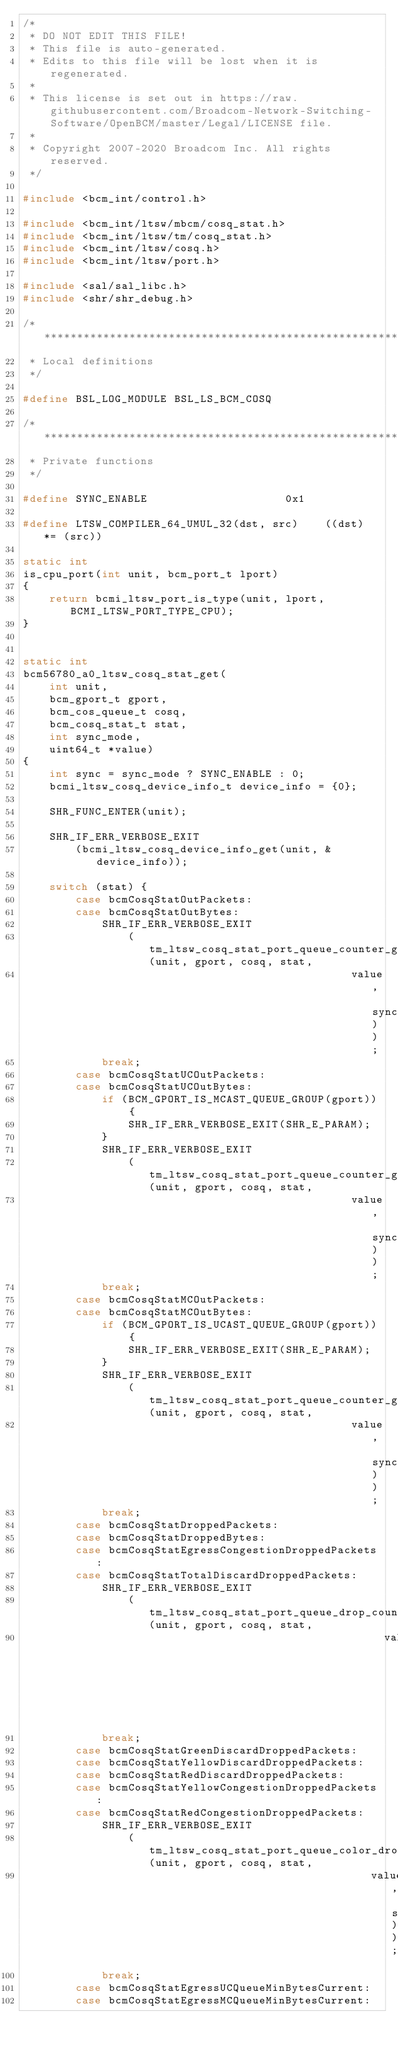<code> <loc_0><loc_0><loc_500><loc_500><_C_>/*
 * DO NOT EDIT THIS FILE!
 * This file is auto-generated.
 * Edits to this file will be lost when it is regenerated.
 *
 * This license is set out in https://raw.githubusercontent.com/Broadcom-Network-Switching-Software/OpenBCM/master/Legal/LICENSE file.
 * 
 * Copyright 2007-2020 Broadcom Inc. All rights reserved.
 */

#include <bcm_int/control.h>

#include <bcm_int/ltsw/mbcm/cosq_stat.h>
#include <bcm_int/ltsw/tm/cosq_stat.h>
#include <bcm_int/ltsw/cosq.h>
#include <bcm_int/ltsw/port.h>

#include <sal/sal_libc.h>
#include <shr/shr_debug.h>

/******************************************************************************
 * Local definitions
 */

#define BSL_LOG_MODULE BSL_LS_BCM_COSQ

/******************************************************************************
 * Private functions
 */

#define SYNC_ENABLE                     0x1

#define LTSW_COMPILER_64_UMUL_32(dst, src)    ((dst) *= (src))

static int
is_cpu_port(int unit, bcm_port_t lport)
{
    return bcmi_ltsw_port_is_type(unit, lport,  BCMI_LTSW_PORT_TYPE_CPU);
}


static int
bcm56780_a0_ltsw_cosq_stat_get(
    int unit,
    bcm_gport_t gport,
    bcm_cos_queue_t cosq,
    bcm_cosq_stat_t stat,
    int sync_mode,
    uint64_t *value)
{
    int sync = sync_mode ? SYNC_ENABLE : 0;
    bcmi_ltsw_cosq_device_info_t device_info = {0};

    SHR_FUNC_ENTER(unit);

    SHR_IF_ERR_VERBOSE_EXIT
        (bcmi_ltsw_cosq_device_info_get(unit, &device_info));

    switch (stat) {
        case bcmCosqStatOutPackets:
        case bcmCosqStatOutBytes:
            SHR_IF_ERR_VERBOSE_EXIT
                (tm_ltsw_cosq_stat_port_queue_counter_get(unit, gport, cosq, stat,
                                                  value, sync));
            break;
        case bcmCosqStatUCOutPackets:
        case bcmCosqStatUCOutBytes:
            if (BCM_GPORT_IS_MCAST_QUEUE_GROUP(gport)) {
                SHR_IF_ERR_VERBOSE_EXIT(SHR_E_PARAM);
            }
            SHR_IF_ERR_VERBOSE_EXIT
                (tm_ltsw_cosq_stat_port_queue_counter_get(unit, gport, cosq, stat,
                                                  value, sync));
            break;
        case bcmCosqStatMCOutPackets:
        case bcmCosqStatMCOutBytes:
            if (BCM_GPORT_IS_UCAST_QUEUE_GROUP(gport)) {
                SHR_IF_ERR_VERBOSE_EXIT(SHR_E_PARAM);
            }
            SHR_IF_ERR_VERBOSE_EXIT
                (tm_ltsw_cosq_stat_port_queue_counter_get(unit, gport, cosq, stat,
                                                  value, sync));
            break;
        case bcmCosqStatDroppedPackets:
        case bcmCosqStatDroppedBytes:
        case bcmCosqStatEgressCongestionDroppedPackets:
        case bcmCosqStatTotalDiscardDroppedPackets:
            SHR_IF_ERR_VERBOSE_EXIT
                (tm_ltsw_cosq_stat_port_queue_drop_counter_get(unit, gport, cosq, stat,
                                                       value, sync));
            break;
        case bcmCosqStatGreenDiscardDroppedPackets:
        case bcmCosqStatYellowDiscardDroppedPackets:
        case bcmCosqStatRedDiscardDroppedPackets:
        case bcmCosqStatYellowCongestionDroppedPackets:
        case bcmCosqStatRedCongestionDroppedPackets:
            SHR_IF_ERR_VERBOSE_EXIT
                (tm_ltsw_cosq_stat_port_queue_color_drop_get(unit, gport, cosq, stat,
                                                     value, sync));
            break;
        case bcmCosqStatEgressUCQueueMinBytesCurrent:
        case bcmCosqStatEgressMCQueueMinBytesCurrent:</code> 